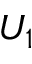<formula> <loc_0><loc_0><loc_500><loc_500>U _ { 1 }</formula> 